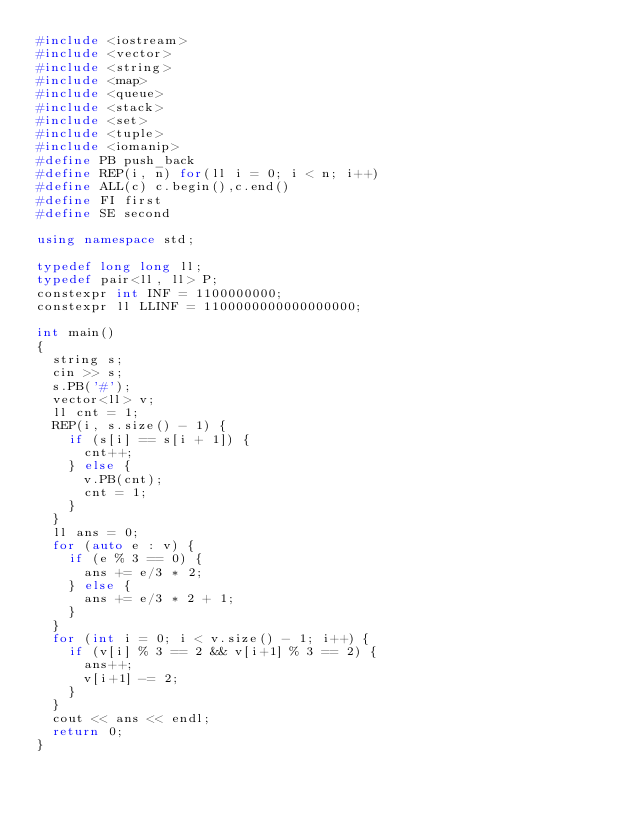Convert code to text. <code><loc_0><loc_0><loc_500><loc_500><_C++_>#include <iostream>
#include <vector>
#include <string>
#include <map>
#include <queue>
#include <stack>
#include <set>
#include <tuple>
#include <iomanip>
#define PB push_back
#define REP(i, n) for(ll i = 0; i < n; i++)
#define ALL(c) c.begin(),c.end()
#define FI first
#define SE second

using namespace std;

typedef long long ll;
typedef pair<ll, ll> P;
constexpr int INF = 1100000000;
constexpr ll LLINF = 1100000000000000000;

int main()
{
  string s;
  cin >> s;
  s.PB('#');
  vector<ll> v;
  ll cnt = 1;
  REP(i, s.size() - 1) {
    if (s[i] == s[i + 1]) {
      cnt++;
    } else {
      v.PB(cnt);
      cnt = 1;
    }
  }
  ll ans = 0;
  for (auto e : v) {
    if (e % 3 == 0) {
      ans += e/3 * 2;
    } else {
      ans += e/3 * 2 + 1;
    }
  }
  for (int i = 0; i < v.size() - 1; i++) {
    if (v[i] % 3 == 2 && v[i+1] % 3 == 2) {
      ans++;
      v[i+1] -= 2;
    }
  }
  cout << ans << endl;
  return 0;
}
</code> 